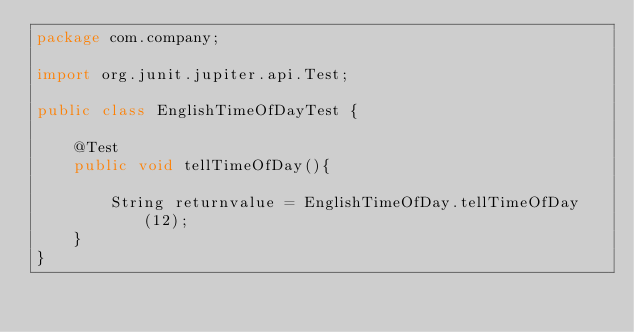Convert code to text. <code><loc_0><loc_0><loc_500><loc_500><_Java_>package com.company;

import org.junit.jupiter.api.Test;

public class EnglishTimeOfDayTest {

    @Test
    public void tellTimeOfDay(){

        String returnvalue = EnglishTimeOfDay.tellTimeOfDay(12);
    }
}
</code> 